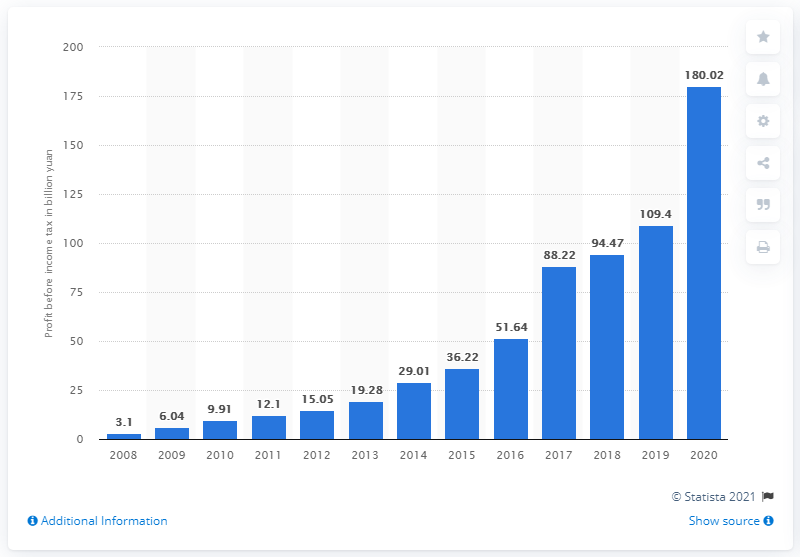Indicate a few pertinent items in this graphic. Tencent's profit before income tax in the fiscal year 2020 was 180.02. 